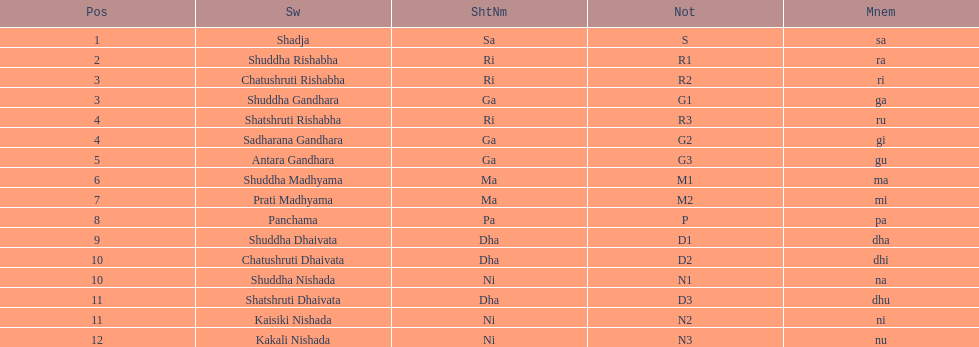What's the sum of all listed positions? 16. 